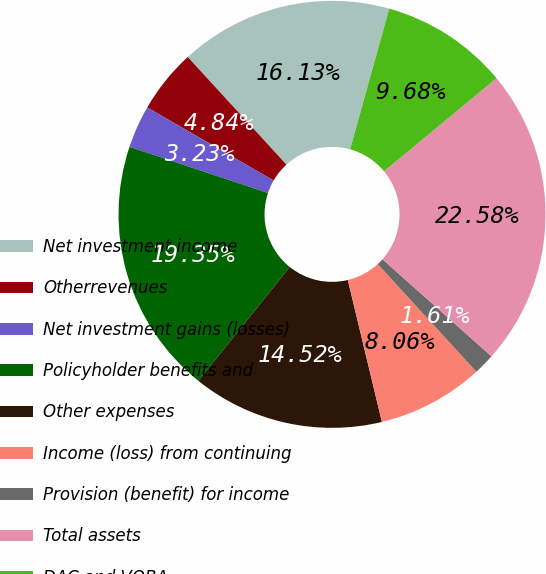Convert chart to OTSL. <chart><loc_0><loc_0><loc_500><loc_500><pie_chart><fcel>Net investment income<fcel>Otherrevenues<fcel>Net investment gains (losses)<fcel>Policyholder benefits and<fcel>Other expenses<fcel>Income (loss) from continuing<fcel>Provision (benefit) for income<fcel>Total assets<fcel>DAC and VOBA<nl><fcel>16.13%<fcel>4.84%<fcel>3.23%<fcel>19.35%<fcel>14.52%<fcel>8.06%<fcel>1.61%<fcel>22.58%<fcel>9.68%<nl></chart> 